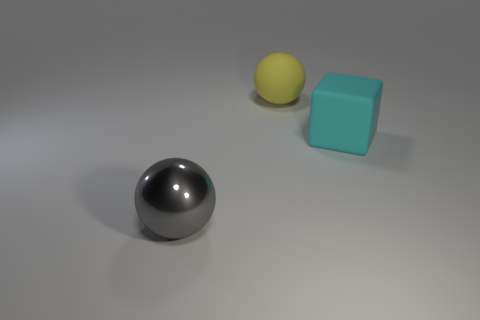What could be the possible use of these objects in this context? These objects could be part of a visualization in a design or art context, perhaps serving as simple models for studying form, shadows, and reflections or for aesthetic composition. 